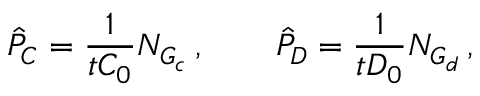<formula> <loc_0><loc_0><loc_500><loc_500>\hat { P } _ { C } = \frac { 1 } { t C _ { 0 } } N _ { G _ { c } } \, , \quad \hat { P } _ { D } = \frac { 1 } { t D _ { 0 } } N _ { G _ { d } } \, ,</formula> 